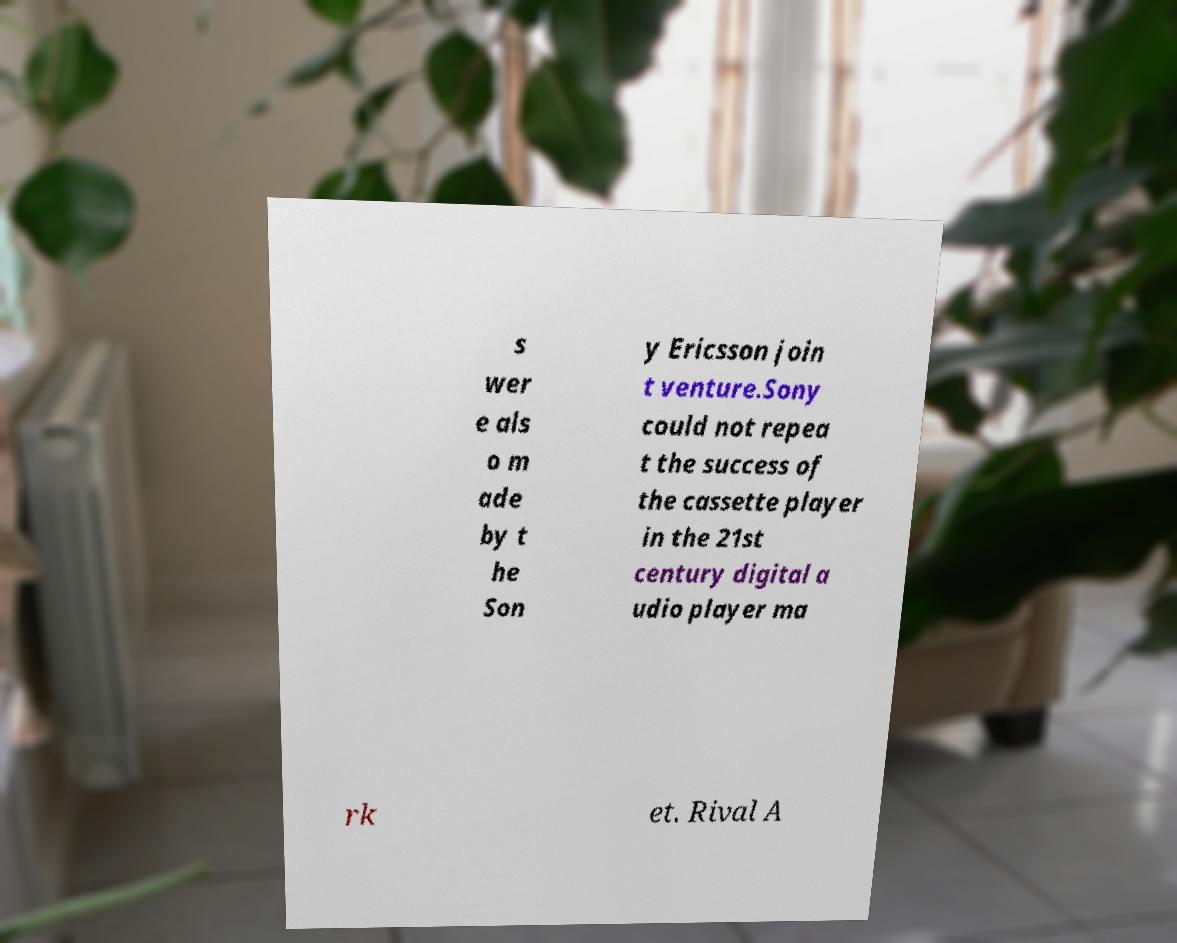I need the written content from this picture converted into text. Can you do that? s wer e als o m ade by t he Son y Ericsson join t venture.Sony could not repea t the success of the cassette player in the 21st century digital a udio player ma rk et. Rival A 